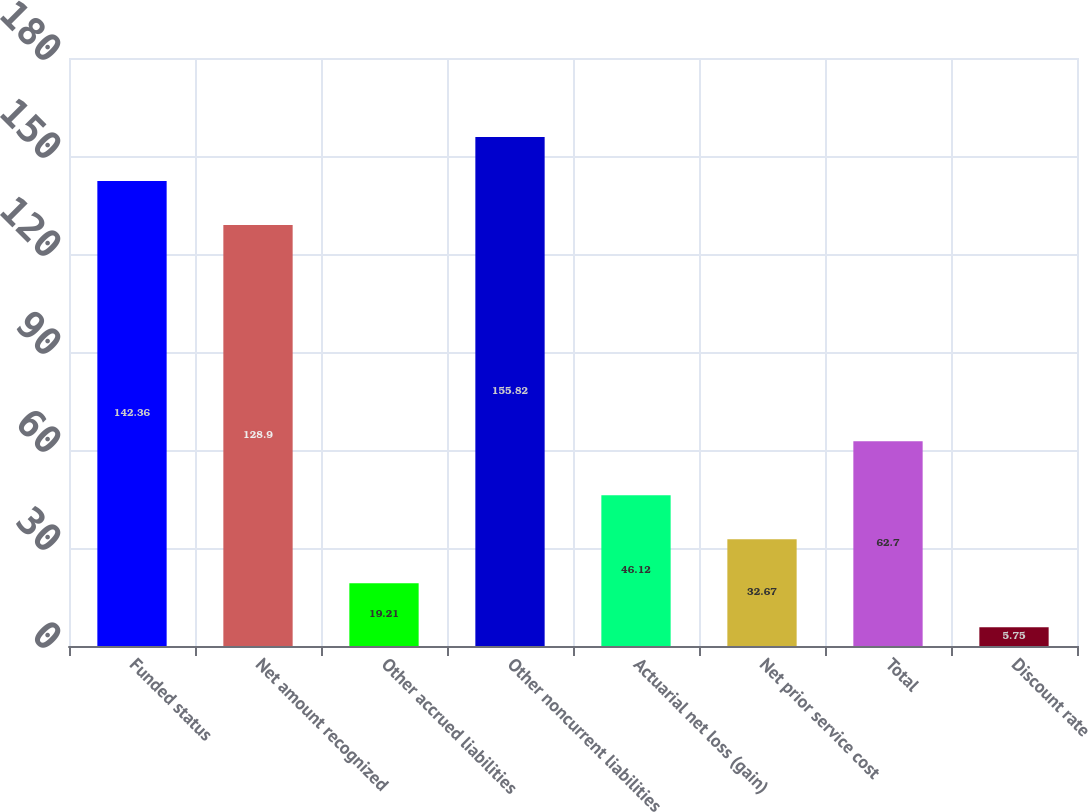Convert chart to OTSL. <chart><loc_0><loc_0><loc_500><loc_500><bar_chart><fcel>Funded status<fcel>Net amount recognized<fcel>Other accrued liabilities<fcel>Other noncurrent liabilities<fcel>Actuarial net loss (gain)<fcel>Net prior service cost<fcel>Total<fcel>Discount rate<nl><fcel>142.36<fcel>128.9<fcel>19.21<fcel>155.82<fcel>46.12<fcel>32.67<fcel>62.7<fcel>5.75<nl></chart> 